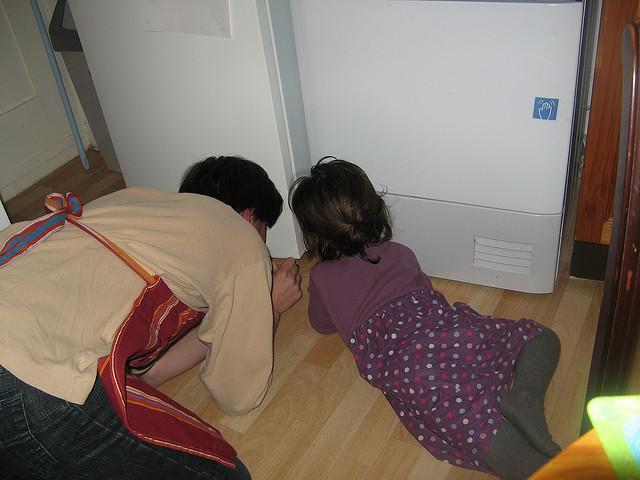How many people are shown this picture?
Give a very brief answer. 2. How many people are in the photo?
Give a very brief answer. 2. How many cats are there?
Give a very brief answer. 0. How many people are in the room?
Give a very brief answer. 2. How many refrigerators are in the picture?
Give a very brief answer. 2. How many people can be seen?
Give a very brief answer. 2. 